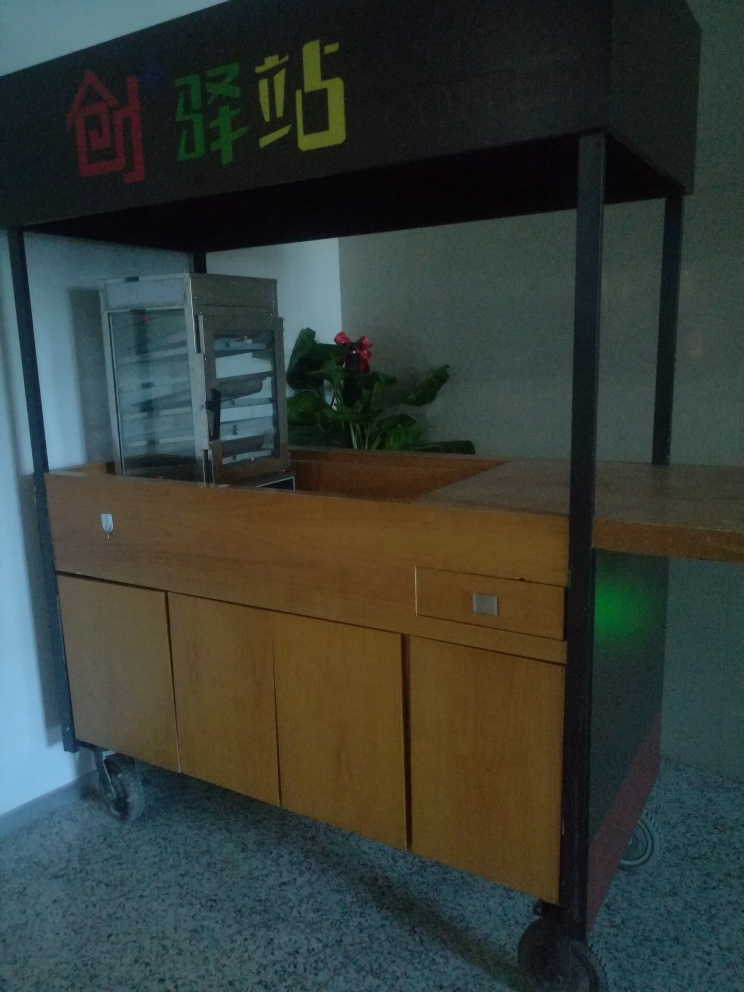Can you describe the setting of this photo? The photo appears to capture a dimly-lit indoor space, likely within a commercial or institutional building, given the information desk and signage. There's a cabinet possibly containing informational brochures or sheets, and a potted plant adding a touch of greenery to the space. The signage includes a bold graphical element and characters, which might indicate a specific section or function of the location. 